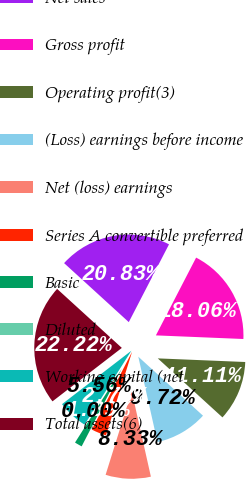<chart> <loc_0><loc_0><loc_500><loc_500><pie_chart><fcel>Net sales<fcel>Gross profit<fcel>Operating profit(3)<fcel>(Loss) earnings before income<fcel>Net (loss) earnings<fcel>Series A convertible preferred<fcel>Basic<fcel>Diluted<fcel>Working capital (net<fcel>Total assets(6)<nl><fcel>20.83%<fcel>18.06%<fcel>11.11%<fcel>9.72%<fcel>8.33%<fcel>2.78%<fcel>1.39%<fcel>0.0%<fcel>5.56%<fcel>22.22%<nl></chart> 